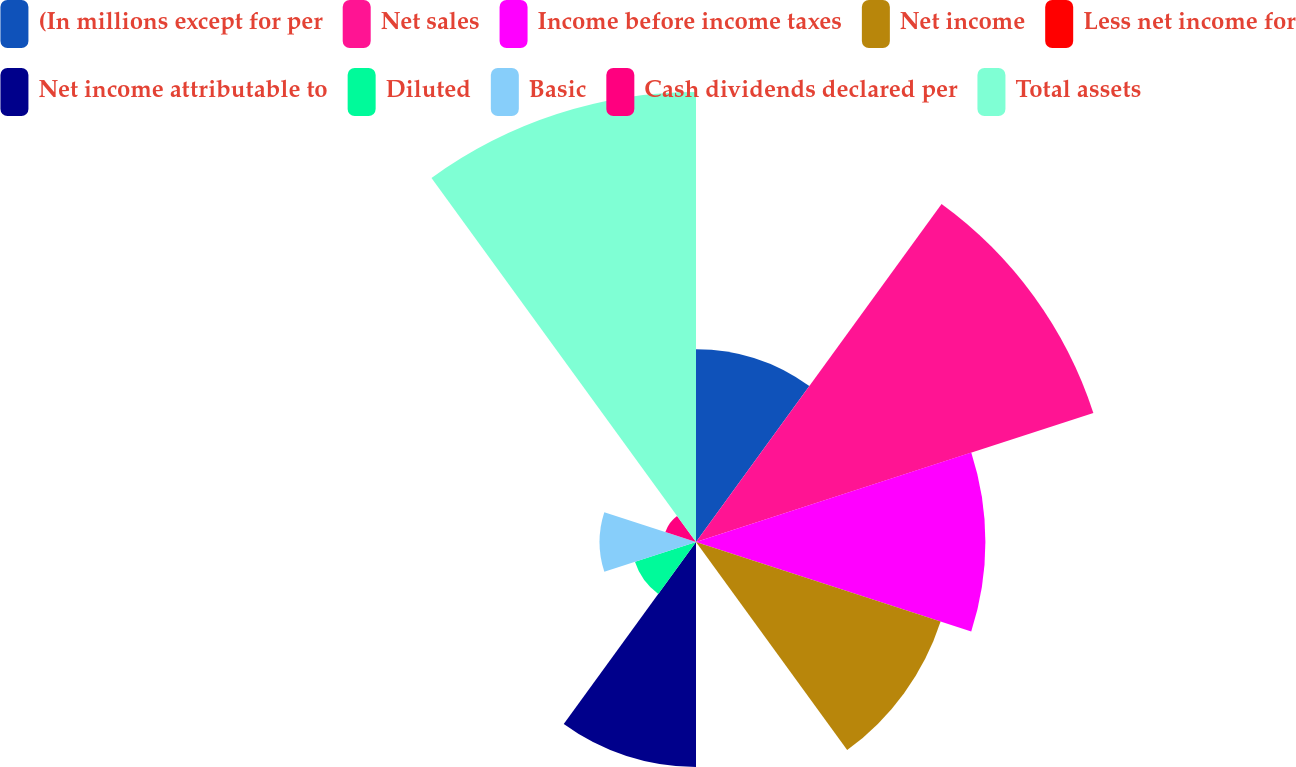Convert chart. <chart><loc_0><loc_0><loc_500><loc_500><pie_chart><fcel>(In millions except for per<fcel>Net sales<fcel>Income before income taxes<fcel>Net income<fcel>Less net income for<fcel>Net income attributable to<fcel>Diluted<fcel>Basic<fcel>Cash dividends declared per<fcel>Total assets<nl><fcel>9.52%<fcel>20.63%<fcel>14.29%<fcel>12.7%<fcel>0.0%<fcel>11.11%<fcel>3.17%<fcel>4.76%<fcel>1.59%<fcel>22.22%<nl></chart> 